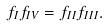<formula> <loc_0><loc_0><loc_500><loc_500>f _ { I } f _ { I V } = f _ { I I } f _ { I I I } .</formula> 